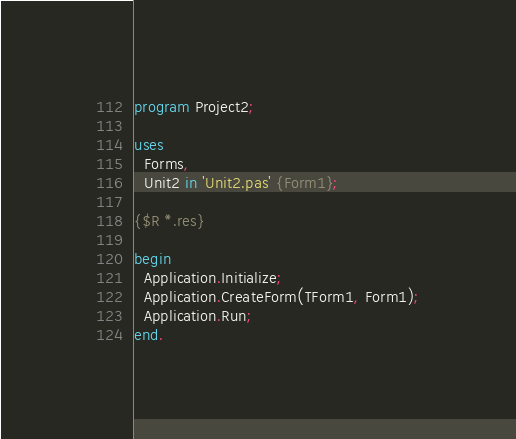Convert code to text. <code><loc_0><loc_0><loc_500><loc_500><_Pascal_>program Project2;

uses
  Forms,
  Unit2 in 'Unit2.pas' {Form1};

{$R *.res}

begin
  Application.Initialize;
  Application.CreateForm(TForm1, Form1);
  Application.Run;
end.
</code> 